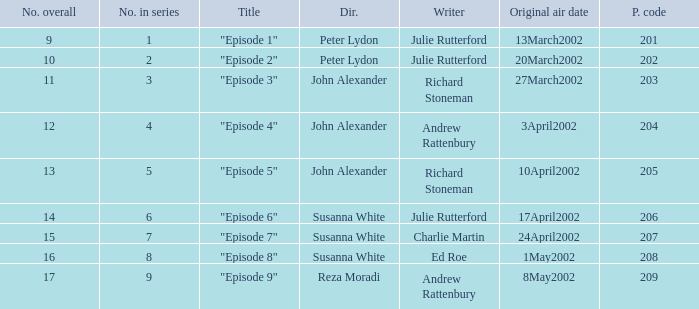When 15 is the number overall what is the original air date? 24April2002. 